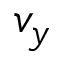Convert formula to latex. <formula><loc_0><loc_0><loc_500><loc_500>v _ { y }</formula> 